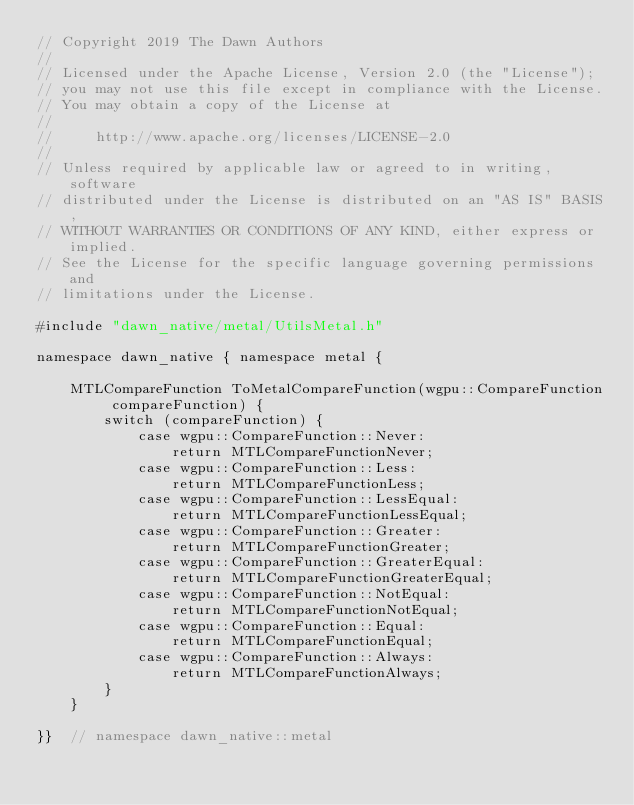Convert code to text. <code><loc_0><loc_0><loc_500><loc_500><_ObjectiveC_>// Copyright 2019 The Dawn Authors
//
// Licensed under the Apache License, Version 2.0 (the "License");
// you may not use this file except in compliance with the License.
// You may obtain a copy of the License at
//
//     http://www.apache.org/licenses/LICENSE-2.0
//
// Unless required by applicable law or agreed to in writing, software
// distributed under the License is distributed on an "AS IS" BASIS,
// WITHOUT WARRANTIES OR CONDITIONS OF ANY KIND, either express or implied.
// See the License for the specific language governing permissions and
// limitations under the License.

#include "dawn_native/metal/UtilsMetal.h"

namespace dawn_native { namespace metal {

    MTLCompareFunction ToMetalCompareFunction(wgpu::CompareFunction compareFunction) {
        switch (compareFunction) {
            case wgpu::CompareFunction::Never:
                return MTLCompareFunctionNever;
            case wgpu::CompareFunction::Less:
                return MTLCompareFunctionLess;
            case wgpu::CompareFunction::LessEqual:
                return MTLCompareFunctionLessEqual;
            case wgpu::CompareFunction::Greater:
                return MTLCompareFunctionGreater;
            case wgpu::CompareFunction::GreaterEqual:
                return MTLCompareFunctionGreaterEqual;
            case wgpu::CompareFunction::NotEqual:
                return MTLCompareFunctionNotEqual;
            case wgpu::CompareFunction::Equal:
                return MTLCompareFunctionEqual;
            case wgpu::CompareFunction::Always:
                return MTLCompareFunctionAlways;
        }
    }

}}  // namespace dawn_native::metal
</code> 